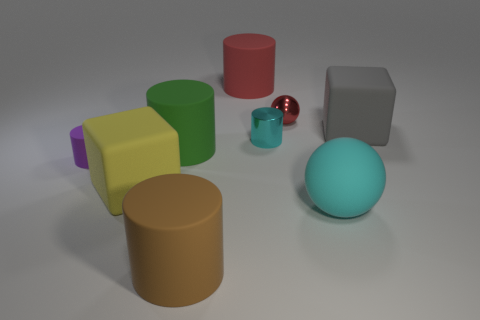The brown cylinder that is made of the same material as the big gray thing is what size?
Your response must be concise. Large. There is a big matte cube left of the large brown thing; what number of large blocks are on the right side of it?
Your answer should be very brief. 1. Do the small cylinder that is to the left of the large brown rubber cylinder and the brown cylinder have the same material?
Offer a terse response. Yes. Is there anything else that has the same material as the small red thing?
Keep it short and to the point. Yes. There is a block that is behind the large matte cube that is in front of the green rubber thing; what size is it?
Your answer should be very brief. Large. There is a metallic thing that is behind the large cube right of the matte cylinder that is in front of the tiny purple thing; how big is it?
Ensure brevity in your answer.  Small. There is a red object that is in front of the red rubber object; is it the same shape as the large rubber object that is in front of the large cyan rubber thing?
Your answer should be very brief. No. How many other objects are there of the same color as the small sphere?
Provide a succinct answer. 1. Does the cyan object that is behind the rubber ball have the same size as the big green rubber object?
Make the answer very short. No. Are the small cylinder that is to the left of the big brown object and the big block that is in front of the gray rubber cube made of the same material?
Your answer should be very brief. Yes. 